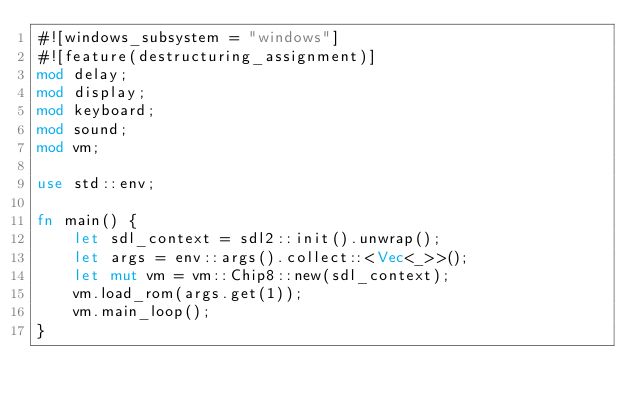<code> <loc_0><loc_0><loc_500><loc_500><_Rust_>#![windows_subsystem = "windows"]
#![feature(destructuring_assignment)]
mod delay;
mod display;
mod keyboard;
mod sound;
mod vm;

use std::env;

fn main() {
    let sdl_context = sdl2::init().unwrap();
    let args = env::args().collect::<Vec<_>>();
    let mut vm = vm::Chip8::new(sdl_context);
    vm.load_rom(args.get(1));
    vm.main_loop();
}
</code> 